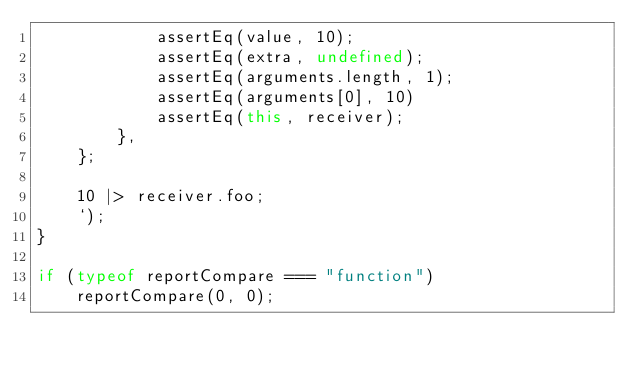<code> <loc_0><loc_0><loc_500><loc_500><_JavaScript_>            assertEq(value, 10);
            assertEq(extra, undefined);
            assertEq(arguments.length, 1);
            assertEq(arguments[0], 10)
            assertEq(this, receiver);
        },
    };

    10 |> receiver.foo;
    `);
}

if (typeof reportCompare === "function")
    reportCompare(0, 0);
</code> 